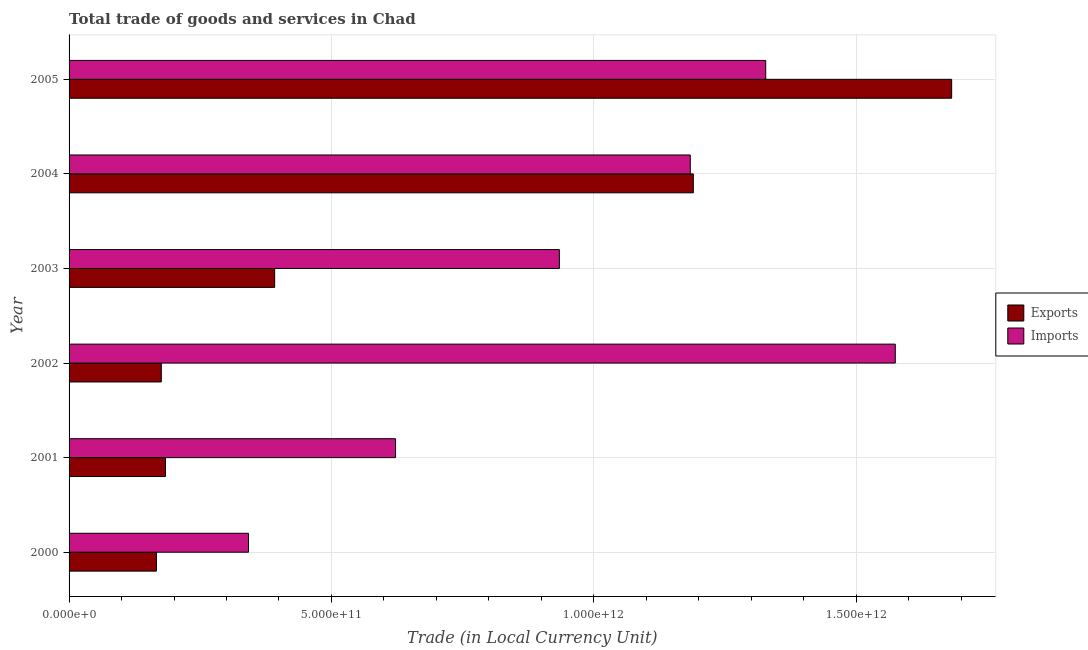How many different coloured bars are there?
Your response must be concise. 2. How many groups of bars are there?
Offer a terse response. 6. Are the number of bars per tick equal to the number of legend labels?
Your answer should be very brief. Yes. How many bars are there on the 3rd tick from the top?
Offer a very short reply. 2. How many bars are there on the 4th tick from the bottom?
Ensure brevity in your answer.  2. What is the label of the 6th group of bars from the top?
Offer a very short reply. 2000. What is the imports of goods and services in 2004?
Ensure brevity in your answer.  1.18e+12. Across all years, what is the maximum export of goods and services?
Give a very brief answer. 1.68e+12. Across all years, what is the minimum export of goods and services?
Provide a short and direct response. 1.67e+11. What is the total export of goods and services in the graph?
Keep it short and to the point. 3.79e+12. What is the difference between the export of goods and services in 2001 and that in 2005?
Offer a very short reply. -1.50e+12. What is the difference between the imports of goods and services in 2000 and the export of goods and services in 2003?
Provide a succinct answer. -4.98e+1. What is the average imports of goods and services per year?
Give a very brief answer. 9.97e+11. In the year 2005, what is the difference between the imports of goods and services and export of goods and services?
Offer a very short reply. -3.54e+11. What is the ratio of the export of goods and services in 2001 to that in 2005?
Your answer should be very brief. 0.11. Is the difference between the export of goods and services in 2001 and 2004 greater than the difference between the imports of goods and services in 2001 and 2004?
Your answer should be very brief. No. What is the difference between the highest and the second highest imports of goods and services?
Keep it short and to the point. 2.47e+11. What is the difference between the highest and the lowest export of goods and services?
Keep it short and to the point. 1.52e+12. Is the sum of the export of goods and services in 2002 and 2005 greater than the maximum imports of goods and services across all years?
Your response must be concise. Yes. What does the 2nd bar from the top in 2001 represents?
Ensure brevity in your answer.  Exports. What does the 2nd bar from the bottom in 2002 represents?
Your answer should be compact. Imports. Are all the bars in the graph horizontal?
Your response must be concise. Yes. What is the difference between two consecutive major ticks on the X-axis?
Offer a terse response. 5.00e+11. Where does the legend appear in the graph?
Offer a very short reply. Center right. How many legend labels are there?
Your answer should be very brief. 2. How are the legend labels stacked?
Make the answer very short. Vertical. What is the title of the graph?
Your answer should be compact. Total trade of goods and services in Chad. What is the label or title of the X-axis?
Ensure brevity in your answer.  Trade (in Local Currency Unit). What is the label or title of the Y-axis?
Give a very brief answer. Year. What is the Trade (in Local Currency Unit) in Exports in 2000?
Make the answer very short. 1.67e+11. What is the Trade (in Local Currency Unit) in Imports in 2000?
Ensure brevity in your answer.  3.42e+11. What is the Trade (in Local Currency Unit) in Exports in 2001?
Keep it short and to the point. 1.84e+11. What is the Trade (in Local Currency Unit) in Imports in 2001?
Offer a very short reply. 6.22e+11. What is the Trade (in Local Currency Unit) in Exports in 2002?
Give a very brief answer. 1.76e+11. What is the Trade (in Local Currency Unit) in Imports in 2002?
Offer a terse response. 1.57e+12. What is the Trade (in Local Currency Unit) of Exports in 2003?
Give a very brief answer. 3.92e+11. What is the Trade (in Local Currency Unit) in Imports in 2003?
Offer a very short reply. 9.34e+11. What is the Trade (in Local Currency Unit) of Exports in 2004?
Keep it short and to the point. 1.19e+12. What is the Trade (in Local Currency Unit) of Imports in 2004?
Ensure brevity in your answer.  1.18e+12. What is the Trade (in Local Currency Unit) of Exports in 2005?
Ensure brevity in your answer.  1.68e+12. What is the Trade (in Local Currency Unit) of Imports in 2005?
Offer a terse response. 1.33e+12. Across all years, what is the maximum Trade (in Local Currency Unit) in Exports?
Ensure brevity in your answer.  1.68e+12. Across all years, what is the maximum Trade (in Local Currency Unit) in Imports?
Your answer should be compact. 1.57e+12. Across all years, what is the minimum Trade (in Local Currency Unit) in Exports?
Ensure brevity in your answer.  1.67e+11. Across all years, what is the minimum Trade (in Local Currency Unit) of Imports?
Offer a very short reply. 3.42e+11. What is the total Trade (in Local Currency Unit) of Exports in the graph?
Ensure brevity in your answer.  3.79e+12. What is the total Trade (in Local Currency Unit) of Imports in the graph?
Give a very brief answer. 5.98e+12. What is the difference between the Trade (in Local Currency Unit) of Exports in 2000 and that in 2001?
Give a very brief answer. -1.72e+1. What is the difference between the Trade (in Local Currency Unit) in Imports in 2000 and that in 2001?
Keep it short and to the point. -2.80e+11. What is the difference between the Trade (in Local Currency Unit) of Exports in 2000 and that in 2002?
Offer a terse response. -9.24e+09. What is the difference between the Trade (in Local Currency Unit) of Imports in 2000 and that in 2002?
Provide a short and direct response. -1.23e+12. What is the difference between the Trade (in Local Currency Unit) of Exports in 2000 and that in 2003?
Offer a terse response. -2.25e+11. What is the difference between the Trade (in Local Currency Unit) of Imports in 2000 and that in 2003?
Offer a very short reply. -5.92e+11. What is the difference between the Trade (in Local Currency Unit) in Exports in 2000 and that in 2004?
Keep it short and to the point. -1.02e+12. What is the difference between the Trade (in Local Currency Unit) in Imports in 2000 and that in 2004?
Your answer should be compact. -8.42e+11. What is the difference between the Trade (in Local Currency Unit) of Exports in 2000 and that in 2005?
Make the answer very short. -1.52e+12. What is the difference between the Trade (in Local Currency Unit) of Imports in 2000 and that in 2005?
Give a very brief answer. -9.86e+11. What is the difference between the Trade (in Local Currency Unit) in Exports in 2001 and that in 2002?
Make the answer very short. 7.96e+09. What is the difference between the Trade (in Local Currency Unit) in Imports in 2001 and that in 2002?
Keep it short and to the point. -9.52e+11. What is the difference between the Trade (in Local Currency Unit) in Exports in 2001 and that in 2003?
Offer a terse response. -2.08e+11. What is the difference between the Trade (in Local Currency Unit) of Imports in 2001 and that in 2003?
Your answer should be compact. -3.12e+11. What is the difference between the Trade (in Local Currency Unit) of Exports in 2001 and that in 2004?
Keep it short and to the point. -1.01e+12. What is the difference between the Trade (in Local Currency Unit) of Imports in 2001 and that in 2004?
Provide a succinct answer. -5.62e+11. What is the difference between the Trade (in Local Currency Unit) in Exports in 2001 and that in 2005?
Offer a terse response. -1.50e+12. What is the difference between the Trade (in Local Currency Unit) of Imports in 2001 and that in 2005?
Provide a succinct answer. -7.05e+11. What is the difference between the Trade (in Local Currency Unit) in Exports in 2002 and that in 2003?
Your answer should be very brief. -2.16e+11. What is the difference between the Trade (in Local Currency Unit) of Imports in 2002 and that in 2003?
Offer a terse response. 6.40e+11. What is the difference between the Trade (in Local Currency Unit) in Exports in 2002 and that in 2004?
Make the answer very short. -1.01e+12. What is the difference between the Trade (in Local Currency Unit) of Imports in 2002 and that in 2004?
Keep it short and to the point. 3.91e+11. What is the difference between the Trade (in Local Currency Unit) of Exports in 2002 and that in 2005?
Make the answer very short. -1.51e+12. What is the difference between the Trade (in Local Currency Unit) of Imports in 2002 and that in 2005?
Offer a terse response. 2.47e+11. What is the difference between the Trade (in Local Currency Unit) of Exports in 2003 and that in 2004?
Provide a short and direct response. -7.98e+11. What is the difference between the Trade (in Local Currency Unit) in Imports in 2003 and that in 2004?
Offer a very short reply. -2.50e+11. What is the difference between the Trade (in Local Currency Unit) of Exports in 2003 and that in 2005?
Make the answer very short. -1.29e+12. What is the difference between the Trade (in Local Currency Unit) of Imports in 2003 and that in 2005?
Your answer should be compact. -3.93e+11. What is the difference between the Trade (in Local Currency Unit) of Exports in 2004 and that in 2005?
Your response must be concise. -4.92e+11. What is the difference between the Trade (in Local Currency Unit) of Imports in 2004 and that in 2005?
Keep it short and to the point. -1.44e+11. What is the difference between the Trade (in Local Currency Unit) in Exports in 2000 and the Trade (in Local Currency Unit) in Imports in 2001?
Offer a terse response. -4.56e+11. What is the difference between the Trade (in Local Currency Unit) of Exports in 2000 and the Trade (in Local Currency Unit) of Imports in 2002?
Your response must be concise. -1.41e+12. What is the difference between the Trade (in Local Currency Unit) of Exports in 2000 and the Trade (in Local Currency Unit) of Imports in 2003?
Your answer should be very brief. -7.68e+11. What is the difference between the Trade (in Local Currency Unit) in Exports in 2000 and the Trade (in Local Currency Unit) in Imports in 2004?
Your answer should be very brief. -1.02e+12. What is the difference between the Trade (in Local Currency Unit) of Exports in 2000 and the Trade (in Local Currency Unit) of Imports in 2005?
Give a very brief answer. -1.16e+12. What is the difference between the Trade (in Local Currency Unit) of Exports in 2001 and the Trade (in Local Currency Unit) of Imports in 2002?
Your response must be concise. -1.39e+12. What is the difference between the Trade (in Local Currency Unit) of Exports in 2001 and the Trade (in Local Currency Unit) of Imports in 2003?
Your answer should be very brief. -7.51e+11. What is the difference between the Trade (in Local Currency Unit) of Exports in 2001 and the Trade (in Local Currency Unit) of Imports in 2004?
Your answer should be very brief. -1.00e+12. What is the difference between the Trade (in Local Currency Unit) in Exports in 2001 and the Trade (in Local Currency Unit) in Imports in 2005?
Give a very brief answer. -1.14e+12. What is the difference between the Trade (in Local Currency Unit) of Exports in 2002 and the Trade (in Local Currency Unit) of Imports in 2003?
Make the answer very short. -7.59e+11. What is the difference between the Trade (in Local Currency Unit) of Exports in 2002 and the Trade (in Local Currency Unit) of Imports in 2004?
Make the answer very short. -1.01e+12. What is the difference between the Trade (in Local Currency Unit) in Exports in 2002 and the Trade (in Local Currency Unit) in Imports in 2005?
Ensure brevity in your answer.  -1.15e+12. What is the difference between the Trade (in Local Currency Unit) in Exports in 2003 and the Trade (in Local Currency Unit) in Imports in 2004?
Your answer should be compact. -7.92e+11. What is the difference between the Trade (in Local Currency Unit) in Exports in 2003 and the Trade (in Local Currency Unit) in Imports in 2005?
Give a very brief answer. -9.36e+11. What is the difference between the Trade (in Local Currency Unit) of Exports in 2004 and the Trade (in Local Currency Unit) of Imports in 2005?
Keep it short and to the point. -1.38e+11. What is the average Trade (in Local Currency Unit) in Exports per year?
Make the answer very short. 6.32e+11. What is the average Trade (in Local Currency Unit) of Imports per year?
Your response must be concise. 9.97e+11. In the year 2000, what is the difference between the Trade (in Local Currency Unit) of Exports and Trade (in Local Currency Unit) of Imports?
Offer a very short reply. -1.75e+11. In the year 2001, what is the difference between the Trade (in Local Currency Unit) of Exports and Trade (in Local Currency Unit) of Imports?
Ensure brevity in your answer.  -4.38e+11. In the year 2002, what is the difference between the Trade (in Local Currency Unit) in Exports and Trade (in Local Currency Unit) in Imports?
Provide a succinct answer. -1.40e+12. In the year 2003, what is the difference between the Trade (in Local Currency Unit) in Exports and Trade (in Local Currency Unit) in Imports?
Your answer should be very brief. -5.43e+11. In the year 2004, what is the difference between the Trade (in Local Currency Unit) of Exports and Trade (in Local Currency Unit) of Imports?
Keep it short and to the point. 5.81e+09. In the year 2005, what is the difference between the Trade (in Local Currency Unit) of Exports and Trade (in Local Currency Unit) of Imports?
Make the answer very short. 3.54e+11. What is the ratio of the Trade (in Local Currency Unit) of Exports in 2000 to that in 2001?
Offer a very short reply. 0.91. What is the ratio of the Trade (in Local Currency Unit) in Imports in 2000 to that in 2001?
Keep it short and to the point. 0.55. What is the ratio of the Trade (in Local Currency Unit) in Exports in 2000 to that in 2002?
Ensure brevity in your answer.  0.95. What is the ratio of the Trade (in Local Currency Unit) in Imports in 2000 to that in 2002?
Provide a short and direct response. 0.22. What is the ratio of the Trade (in Local Currency Unit) of Exports in 2000 to that in 2003?
Your answer should be very brief. 0.43. What is the ratio of the Trade (in Local Currency Unit) of Imports in 2000 to that in 2003?
Provide a succinct answer. 0.37. What is the ratio of the Trade (in Local Currency Unit) of Exports in 2000 to that in 2004?
Ensure brevity in your answer.  0.14. What is the ratio of the Trade (in Local Currency Unit) in Imports in 2000 to that in 2004?
Your answer should be very brief. 0.29. What is the ratio of the Trade (in Local Currency Unit) in Exports in 2000 to that in 2005?
Your response must be concise. 0.1. What is the ratio of the Trade (in Local Currency Unit) of Imports in 2000 to that in 2005?
Provide a succinct answer. 0.26. What is the ratio of the Trade (in Local Currency Unit) of Exports in 2001 to that in 2002?
Offer a terse response. 1.05. What is the ratio of the Trade (in Local Currency Unit) of Imports in 2001 to that in 2002?
Provide a short and direct response. 0.4. What is the ratio of the Trade (in Local Currency Unit) of Exports in 2001 to that in 2003?
Your answer should be very brief. 0.47. What is the ratio of the Trade (in Local Currency Unit) in Imports in 2001 to that in 2003?
Provide a succinct answer. 0.67. What is the ratio of the Trade (in Local Currency Unit) in Exports in 2001 to that in 2004?
Give a very brief answer. 0.15. What is the ratio of the Trade (in Local Currency Unit) of Imports in 2001 to that in 2004?
Offer a very short reply. 0.53. What is the ratio of the Trade (in Local Currency Unit) in Exports in 2001 to that in 2005?
Make the answer very short. 0.11. What is the ratio of the Trade (in Local Currency Unit) of Imports in 2001 to that in 2005?
Your answer should be compact. 0.47. What is the ratio of the Trade (in Local Currency Unit) of Exports in 2002 to that in 2003?
Offer a very short reply. 0.45. What is the ratio of the Trade (in Local Currency Unit) of Imports in 2002 to that in 2003?
Keep it short and to the point. 1.69. What is the ratio of the Trade (in Local Currency Unit) in Exports in 2002 to that in 2004?
Your answer should be compact. 0.15. What is the ratio of the Trade (in Local Currency Unit) of Imports in 2002 to that in 2004?
Offer a very short reply. 1.33. What is the ratio of the Trade (in Local Currency Unit) of Exports in 2002 to that in 2005?
Give a very brief answer. 0.1. What is the ratio of the Trade (in Local Currency Unit) of Imports in 2002 to that in 2005?
Offer a very short reply. 1.19. What is the ratio of the Trade (in Local Currency Unit) of Exports in 2003 to that in 2004?
Provide a short and direct response. 0.33. What is the ratio of the Trade (in Local Currency Unit) of Imports in 2003 to that in 2004?
Your answer should be compact. 0.79. What is the ratio of the Trade (in Local Currency Unit) in Exports in 2003 to that in 2005?
Make the answer very short. 0.23. What is the ratio of the Trade (in Local Currency Unit) of Imports in 2003 to that in 2005?
Your response must be concise. 0.7. What is the ratio of the Trade (in Local Currency Unit) of Exports in 2004 to that in 2005?
Provide a succinct answer. 0.71. What is the ratio of the Trade (in Local Currency Unit) in Imports in 2004 to that in 2005?
Offer a terse response. 0.89. What is the difference between the highest and the second highest Trade (in Local Currency Unit) in Exports?
Your answer should be very brief. 4.92e+11. What is the difference between the highest and the second highest Trade (in Local Currency Unit) in Imports?
Provide a short and direct response. 2.47e+11. What is the difference between the highest and the lowest Trade (in Local Currency Unit) in Exports?
Give a very brief answer. 1.52e+12. What is the difference between the highest and the lowest Trade (in Local Currency Unit) of Imports?
Ensure brevity in your answer.  1.23e+12. 